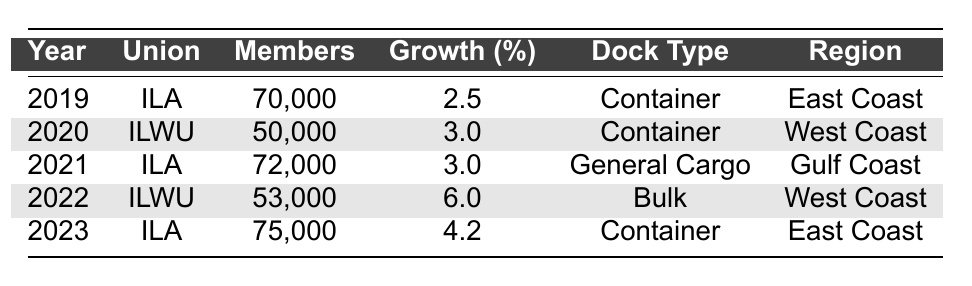What was the total membership of the ILA in 2023? The table shows that the ILA had 75,000 members in 2023.
Answer: 75,000 What was the growth percentage of ILWU in 2022? According to the table, the ILWU had a growth percentage of 6.0% in 2022.
Answer: 6.0% How many total members did ILA have over the five years? To find the total membership of ILA, we add the members for each year (70,000 in 2019 + 72,000 in 2021 + 75,000 in 2023) which equals 217,000.
Answer: 217,000 Which union had the highest membership in a single year? The ILA had the highest membership in 2023 with 75,000 members, which is more than any other year or union listed in the table.
Answer: ILA in 2023 Was there a year when ILWU had a membership greater than ILA? No, the table indicates that the maximum membership for ILWU was 53,000 in 2022, whereas ILA consistently had higher numbers.
Answer: No What was the average growth percentage for ILA from 2019 to 2023? The growth percentages for ILA are 2.5% (2019), 3.0% (2021), and 4.2% (2023). Adding these gives a total of 9.7%, which divided by 3 gives an average of approximately 3.23%.
Answer: Approximately 3.23% Which type of dock had the highest growth percentage and what was that percentage? The highest growth percentage was 6.0% for the ILWU at Bulk docks in 2022.
Answer: 6.0% How many members did the ILWU have in total over the five years? The total membership of ILWU can be calculated by adding its members for each year (50,000 in 2020 + 53,000 in 2022) which totals 103,000.
Answer: 103,000 Which region had the ILA representing container docks, and what were their membership numbers in those years? The ILA represented container docks in the East Coast in 2019 (70,000) and 2023 (75,000).
Answer: East Coast, 70,000 and 75,000 In how many years did the ILWU experience growth? The ILWU had growth in 2020 (3.0%) and 2022 (6.0%), counting two years of growth.
Answer: 2 years Which union had a higher membership in 2021, and what was that number? In 2021, the ILA had 72,000 members, which is more than the ILWU's membership of 53,000 in 2022.
Answer: ILA with 72,000 members in 2021 